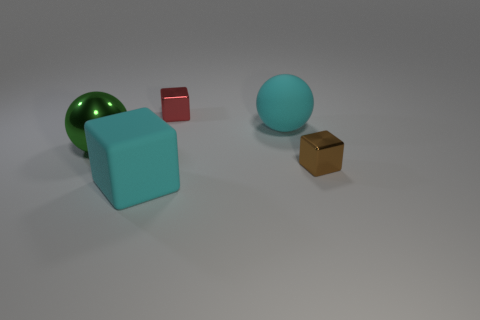What number of other objects are the same material as the cyan block?
Offer a very short reply. 1. There is a ball that is on the left side of the cyan matte cube; does it have the same size as the rubber block?
Offer a terse response. Yes. What number of things are big cyan balls or small brown cubes?
Give a very brief answer. 2. What is the material of the small block behind the metal block that is on the right side of the large cyan thing that is on the right side of the big cyan block?
Make the answer very short. Metal. There is a small cube that is to the right of the tiny red object; what material is it?
Your answer should be very brief. Metal. Are there any yellow rubber cylinders of the same size as the brown shiny thing?
Provide a succinct answer. No. Does the thing on the left side of the matte cube have the same color as the big rubber cube?
Ensure brevity in your answer.  No. How many green objects are large things or big matte blocks?
Your answer should be compact. 1. What number of metal cubes have the same color as the matte ball?
Provide a short and direct response. 0. Is the material of the cyan block the same as the cyan ball?
Offer a terse response. Yes. 